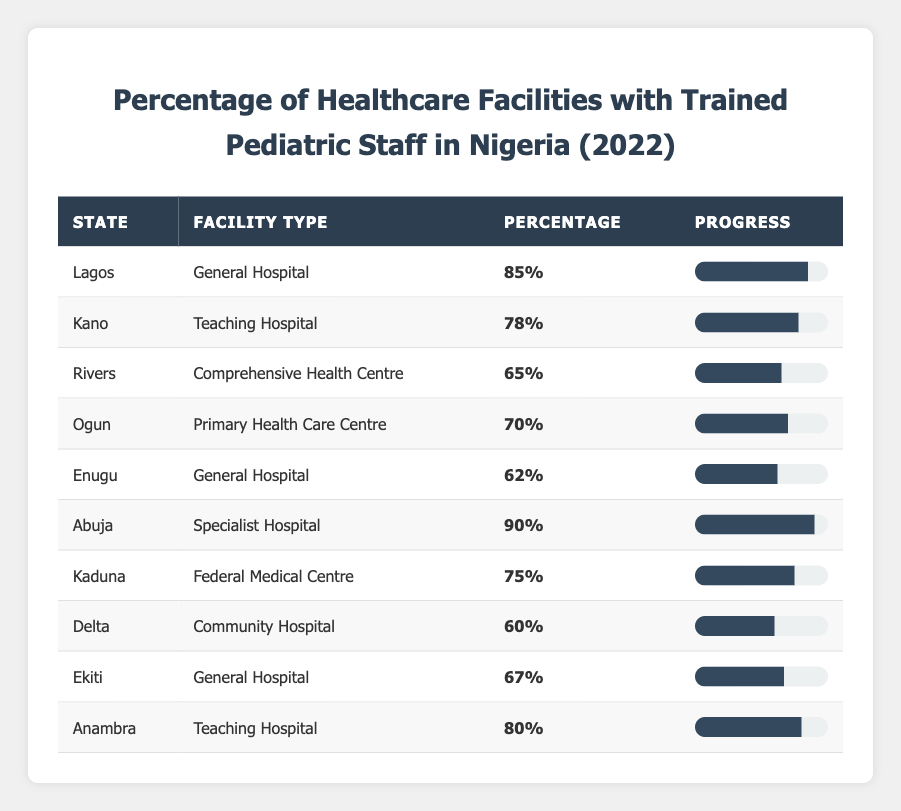What is the highest percentage of trained pediatric staff among the healthcare facilities? By scanning the table, the highest percentage listed is for Abuja at 90%.
Answer: 90% Which state has the lowest percentage of trained pediatric staff? The lowest percentage is found in Delta with 60%.
Answer: 60% What percentage of trained pediatric staff is present in primary health care centers? According to the table, the primary health care center in Ogun has 70% trained pediatric staff.
Answer: 70% Is there any facility in Lagos that has trained pediatric staff above 80%? Yes, Lagos has a general hospital with 85% trained pediatric staff.
Answer: Yes What is the average percentage of trained pediatric staff across all listed healthcare facilities? The sum of the percentages is 85 + 78 + 65 + 70 + 62 + 90 + 75 + 60 + 67 + 80 =  792, and there are 10 facilities. The average is 792/10 = 79.2%.
Answer: 79.2% Which state has a higher percentage of trained pediatric staff: Kano or Kaduna? Kano has 78% while Kaduna has 75%, so Kano has a higher percentage.
Answer: Kano How many healthcare facilities have a trained pediatric staff percentage of 70% or higher? The facilities meeting this criterion are Lagos (85%), Abuja (90%), Kano (78%), Anambra (80%), and Ogun (70%). In total, there are 5 facilities.
Answer: 5 What is the difference in percentage of trained pediatric staff between Abuja and Enugu? Abuja has 90% and Enugu has 62%. The difference is 90 - 62 = 28%.
Answer: 28% Is the percentage of trained pediatric staff in Ekiti greater than the average percentage across all facilities? The average percentage is 79.2%, and Ekiti has 67%, which is less than the average.
Answer: No Which type of facility in Anambra has trained pediatric staff and what is the percentage? Anambra has a Teaching Hospital with 80% trained pediatric staff.
Answer: Teaching Hospital, 80% 